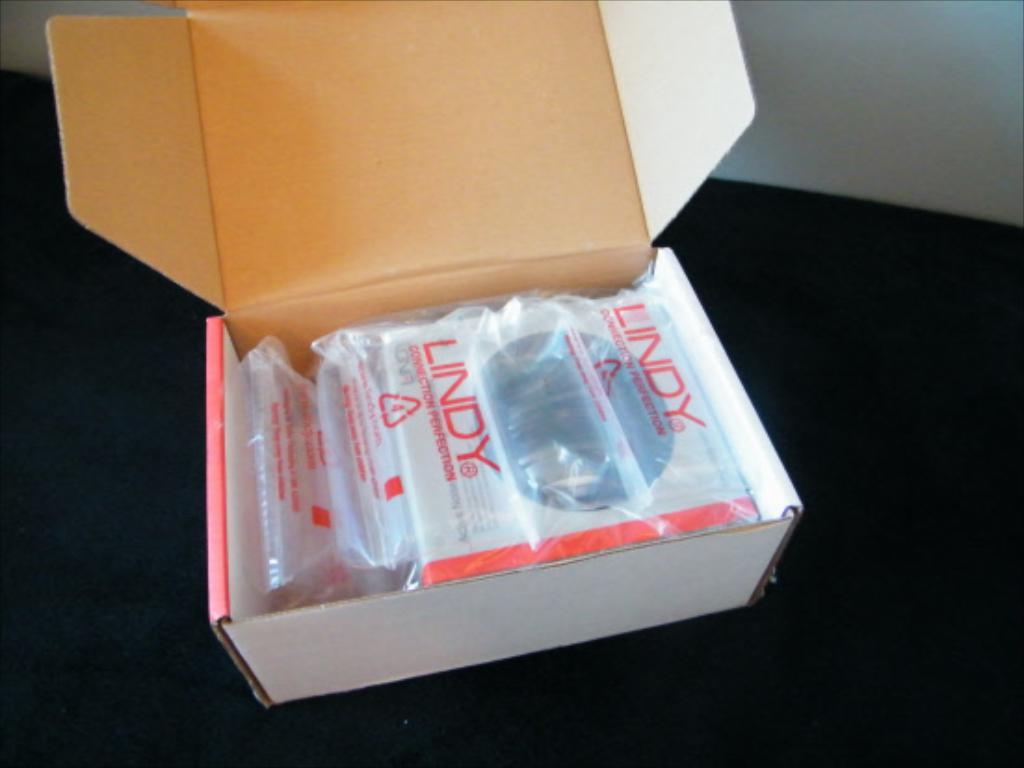Whats the name of the products in the box?
Provide a short and direct response. Lindy. 